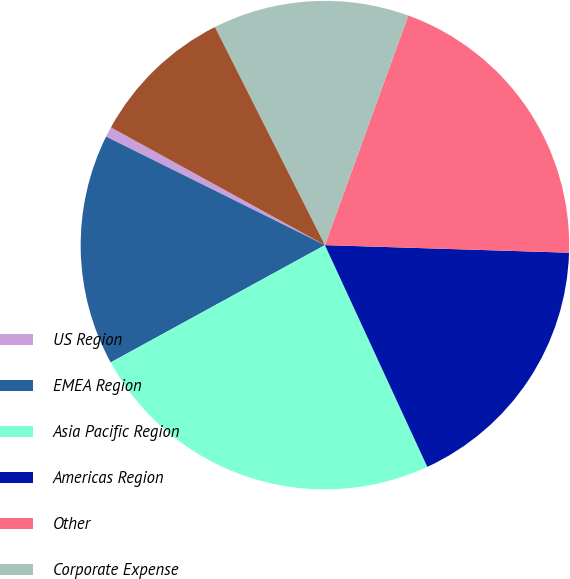<chart> <loc_0><loc_0><loc_500><loc_500><pie_chart><fcel>US Region<fcel>EMEA Region<fcel>Asia Pacific Region<fcel>Americas Region<fcel>Other<fcel>Corporate Expense<fcel>Total Pre-tax Income<nl><fcel>0.68%<fcel>15.3%<fcel>23.91%<fcel>17.62%<fcel>19.95%<fcel>12.98%<fcel>9.56%<nl></chart> 